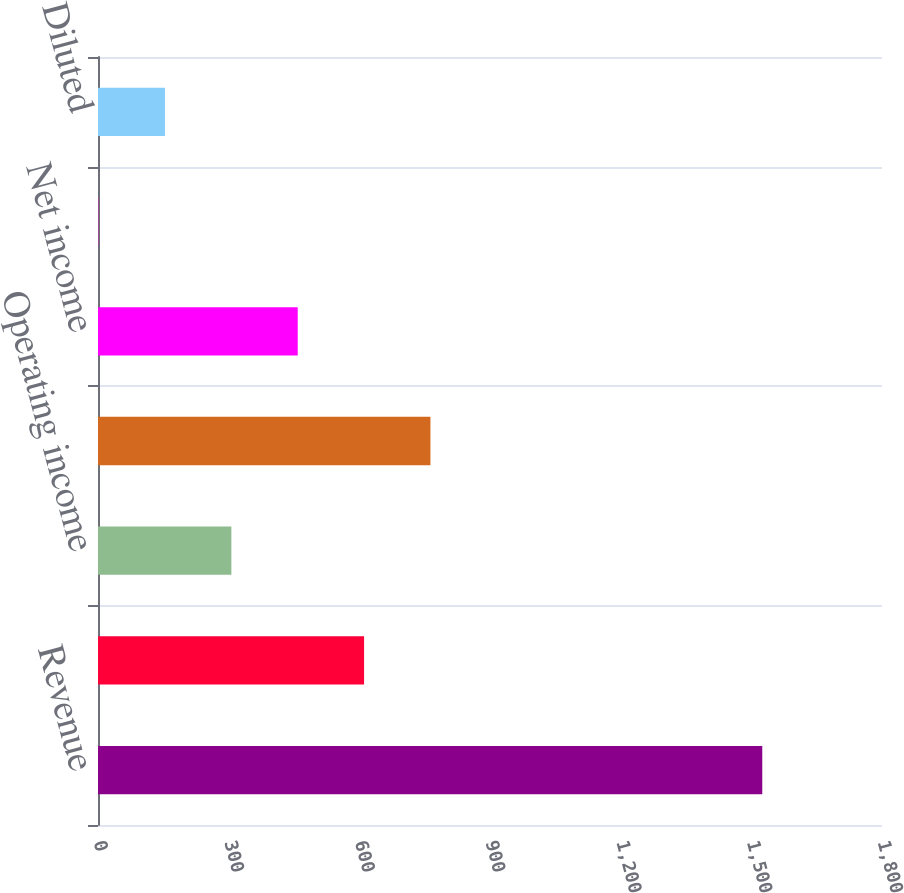Convert chart to OTSL. <chart><loc_0><loc_0><loc_500><loc_500><bar_chart><fcel>Revenue<fcel>Operating income (loss) (a)<fcel>Operating income<fcel>Income (loss) before taxes<fcel>Net income<fcel>Basic<fcel>Diluted<nl><fcel>1525.1<fcel>610.89<fcel>306.17<fcel>763.25<fcel>458.53<fcel>1.45<fcel>153.81<nl></chart> 